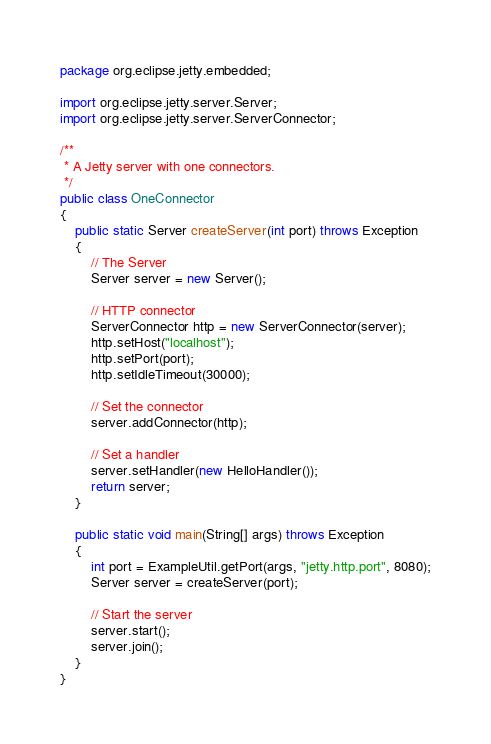<code> <loc_0><loc_0><loc_500><loc_500><_Java_>
package org.eclipse.jetty.embedded;

import org.eclipse.jetty.server.Server;
import org.eclipse.jetty.server.ServerConnector;

/**
 * A Jetty server with one connectors.
 */
public class OneConnector
{
    public static Server createServer(int port) throws Exception
    {
        // The Server
        Server server = new Server();

        // HTTP connector
        ServerConnector http = new ServerConnector(server);
        http.setHost("localhost");
        http.setPort(port);
        http.setIdleTimeout(30000);

        // Set the connector
        server.addConnector(http);

        // Set a handler
        server.setHandler(new HelloHandler());
        return server;
    }

    public static void main(String[] args) throws Exception
    {
        int port = ExampleUtil.getPort(args, "jetty.http.port", 8080);
        Server server = createServer(port);

        // Start the server
        server.start();
        server.join();
    }
}
</code> 